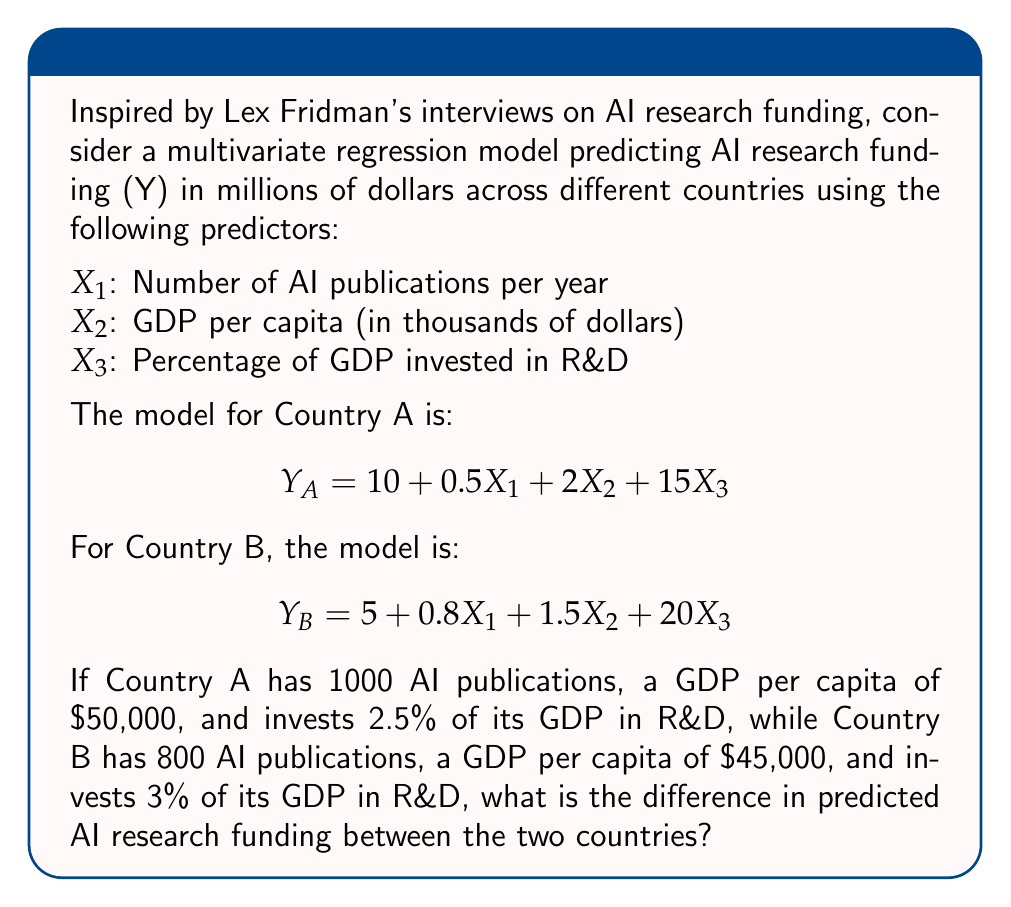Help me with this question. Let's approach this step-by-step:

1. First, we need to calculate the predicted AI research funding for Country A:

   $$Y_A = 10 + 0.5X_1 + 2X_2 + 15X_3$$
   
   Substitute the values:
   X1 = 1000 (publications)
   X2 = 50 (GDP per capita in thousands)
   X3 = 2.5 (percentage of GDP in R&D)

   $$Y_A = 10 + 0.5(1000) + 2(50) + 15(2.5)$$
   $$Y_A = 10 + 500 + 100 + 37.5$$
   $$Y_A = 647.5$$ million dollars

2. Now, let's calculate the predicted AI research funding for Country B:

   $$Y_B = 5 + 0.8X_1 + 1.5X_2 + 20X_3$$
   
   Substitute the values:
   X1 = 800 (publications)
   X2 = 45 (GDP per capita in thousands)
   X3 = 3 (percentage of GDP in R&D)

   $$Y_B = 5 + 0.8(800) + 1.5(45) + 20(3)$$
   $$Y_B = 5 + 640 + 67.5 + 60$$
   $$Y_B = 772.5$$ million dollars

3. To find the difference, we subtract the funding of Country A from Country B:

   Difference = $Y_B - Y_A = 772.5 - 647.5 = 125$ million dollars
Answer: The difference in predicted AI research funding between Country B and Country A is $125 million. 